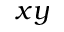Convert formula to latex. <formula><loc_0><loc_0><loc_500><loc_500>x y</formula> 